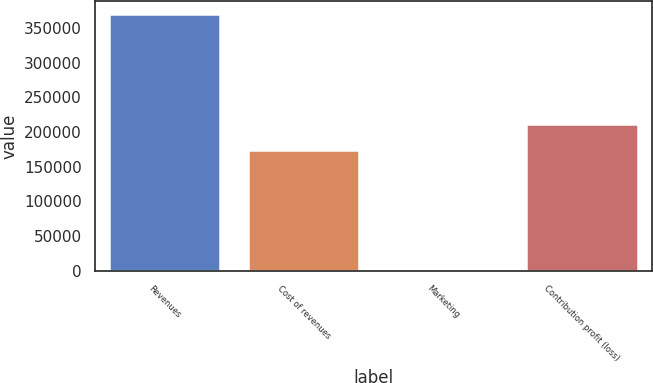<chart> <loc_0><loc_0><loc_500><loc_500><bar_chart><fcel>Revenues<fcel>Cost of revenues<fcel>Marketing<fcel>Contribution profit (loss)<nl><fcel>370253<fcel>174220<fcel>2268<fcel>211018<nl></chart> 